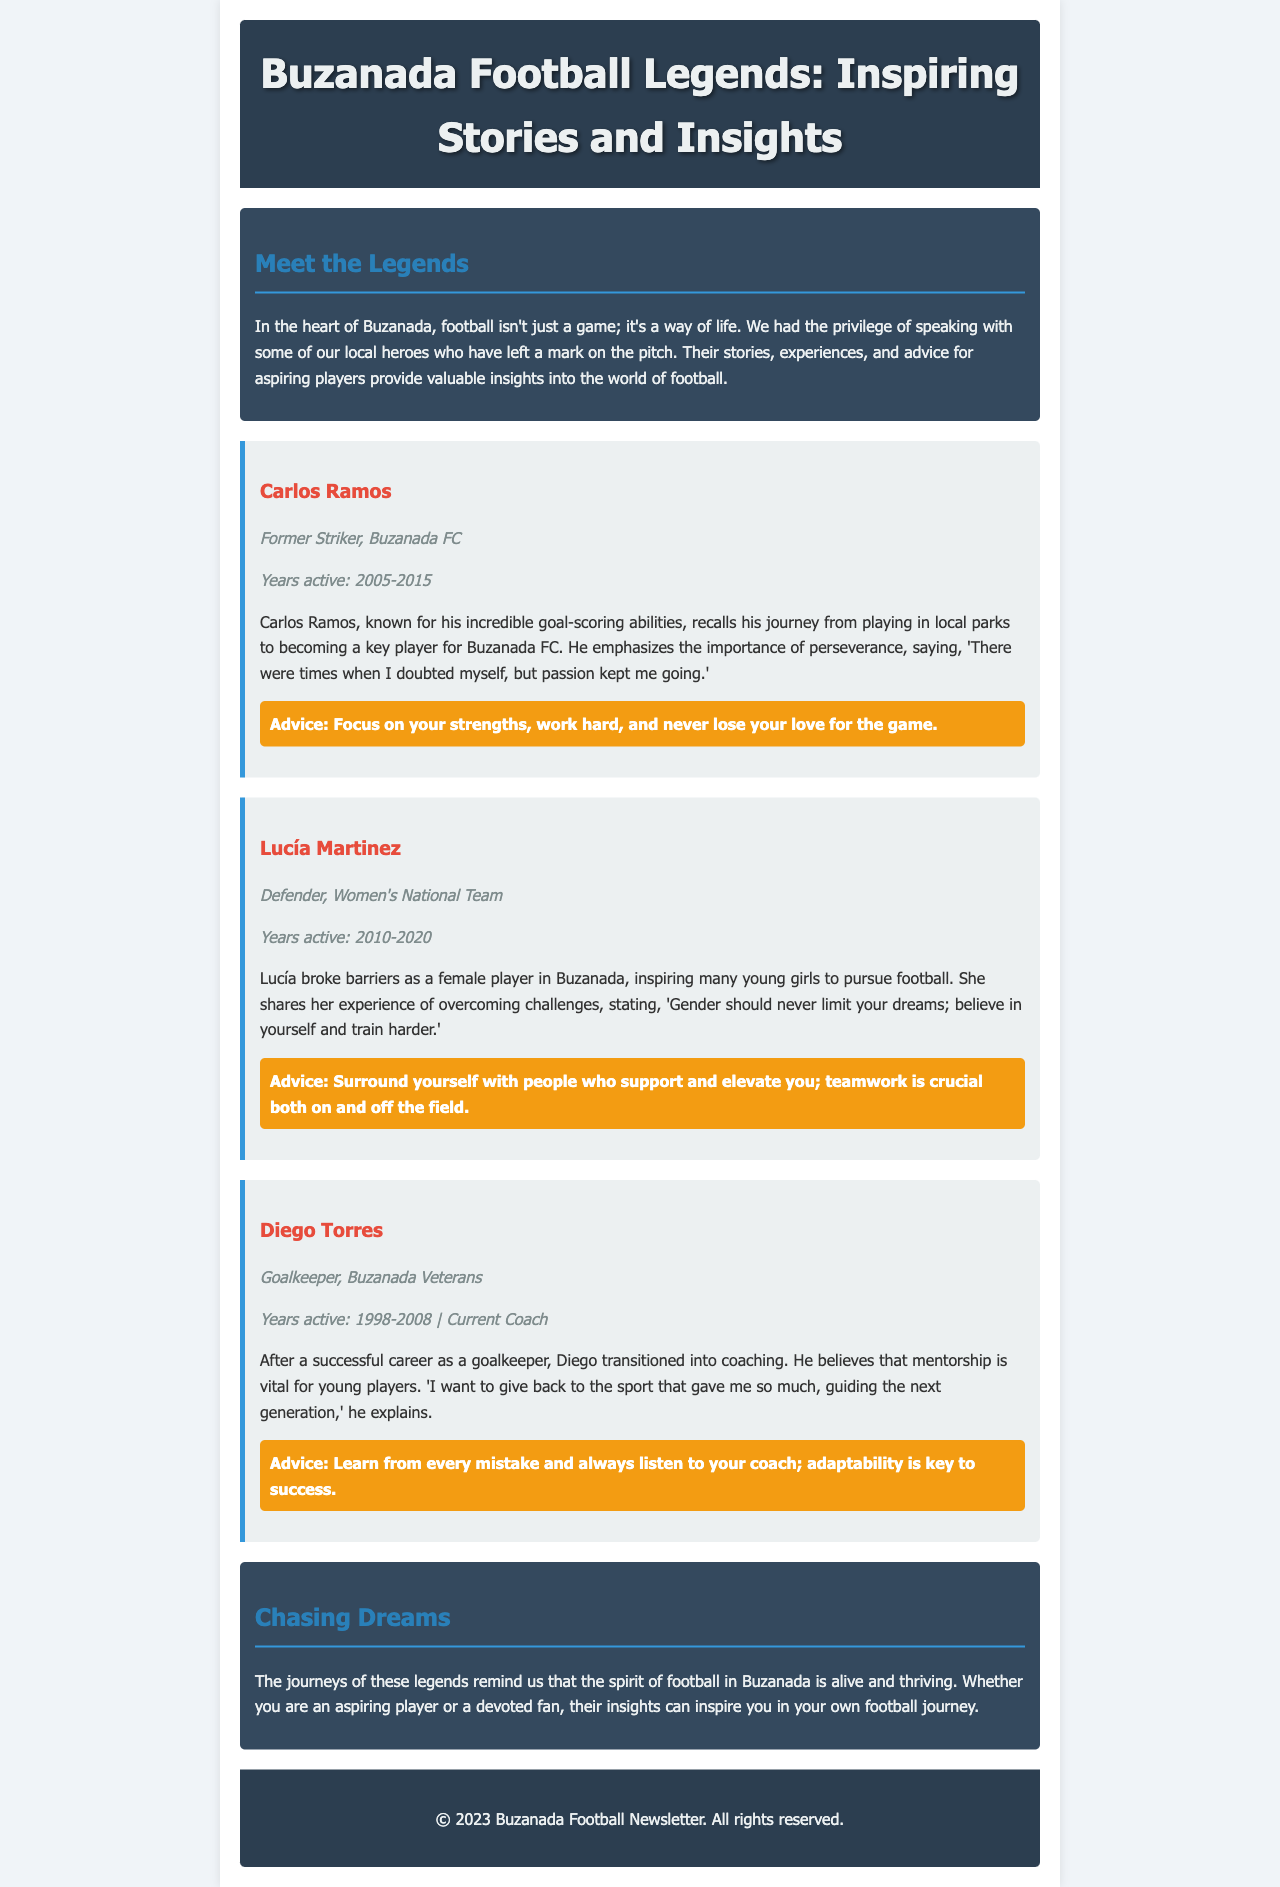What is the title of the newsletter? The title of the newsletter is found in the header section, presenting the main focus of the document.
Answer: Buzanada Football Legends: Inspiring Stories and Insights Who is a former striker for Buzanada FC? This information can be found in the interviews section where players' roles and positions are highlighted.
Answer: Carlos Ramos What years was Lucía Martinez active? The years of activity for Lucía Martinez are mentioned directly in her interview section.
Answer: 2010-2020 What is Diego Torres' current role? The current role of Diego Torres is stated in his interview, indicating his career transition.
Answer: Coach What advice does Carlos Ramos give? The advice provided by Carlos Ramos is directly quoted in his interview section.
Answer: Focus on your strengths, work hard, and never lose your love for the game How did Lucía Martinez contribute to women's football? Her interview section highlights her impact on female players in the local area.
Answer: Inspiring many young girls to pursue football What is the primary theme of the conclusion section? The conclusion summarizes the overall messages from the interviews, highlighting the essence of the stories shared.
Answer: The spirit of football in Buzanada Who is mentioned as a goalkeeper in the document? The document specifically lists players' positions, making it clear who plays in which role.
Answer: Diego Torres What color is the background of the newsletter? This detail can be inferred from the CSS styling included in the code, which is applied to the body element.
Answer: #f0f4f8 